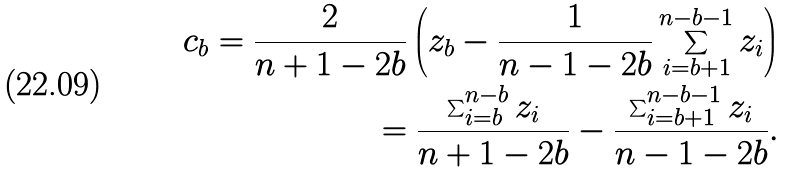Convert formula to latex. <formula><loc_0><loc_0><loc_500><loc_500>c _ { b } = \frac { 2 } { n + 1 - 2 b } \left ( z _ { b } - \frac { 1 } { n - 1 - 2 b } \sum _ { i = b + 1 } ^ { n - b - 1 } z _ { i } \right ) \\ = \frac { \sum _ { i = b } ^ { n - b } z _ { i } } { n + 1 - 2 b } - \frac { \sum _ { i = b + 1 } ^ { n - b - 1 } z _ { i } } { n - 1 - 2 b } .</formula> 